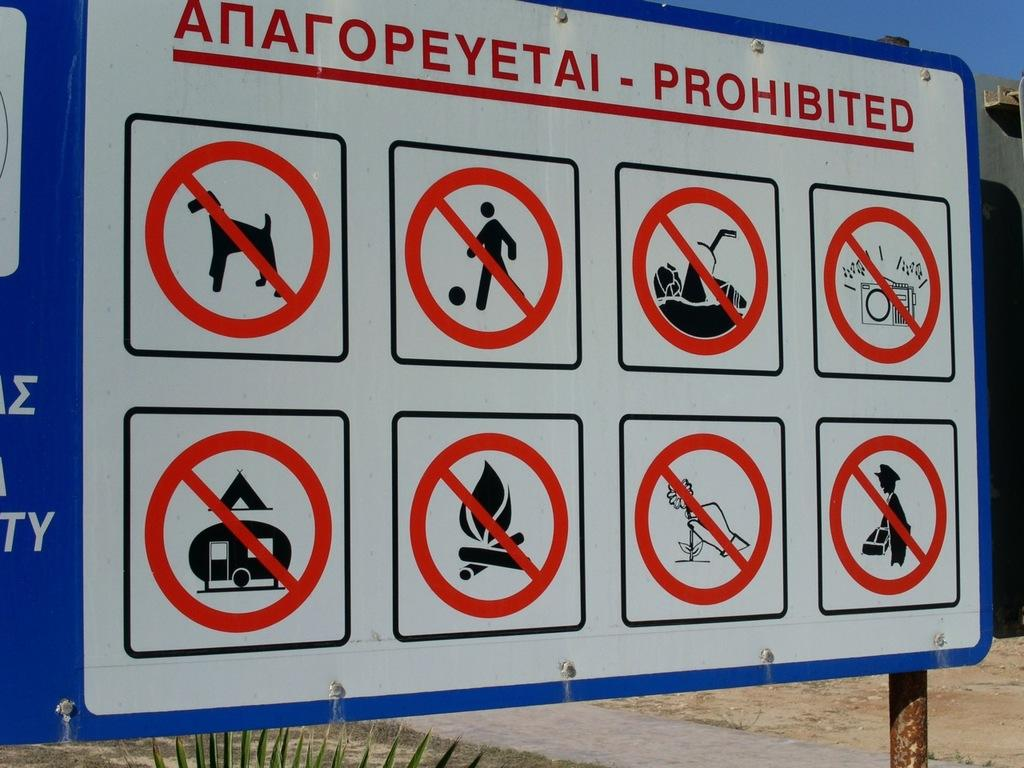<image>
Summarize the visual content of the image. A sign displays many actions as PROHIBITED, including campfires and dogs. 